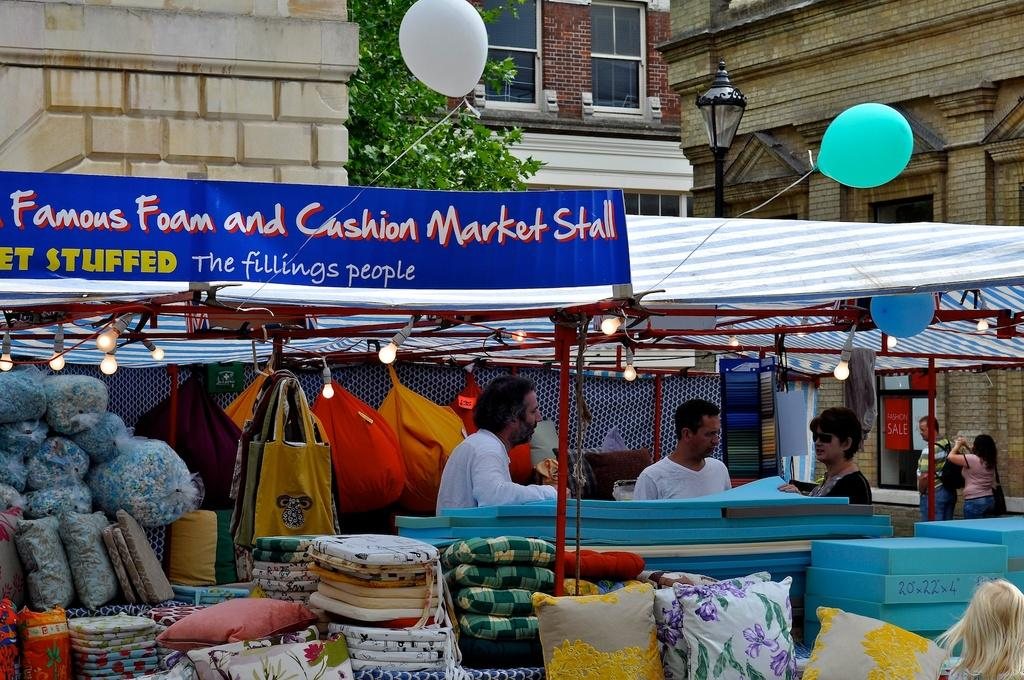What type of structures are present in the image? There are stalls in the image. How many people can be seen in the image? There are five persons in the image. What items are visible in the image that might be used for comfort or decoration? There are pillows in the image. What objects might people use to carry items in the image? There are bags in the image. What type of illumination is present in the image? There are lights in the image. What additional decorative items can be seen in the image? There are balloons in the image. What type of items are being sold or displayed in the stalls? There are clothes in the image. What is the main writing surface in the image? There is a board in the image. What background elements can be seen in the image? There is a pole, a tree, and buildings in the background of the image. How many horses are tied to the pole in the background of the image? There are no horses present in the image; only a pole, a tree, and buildings can be seen in the background. What type of boat is floating in the air above the stalls in the image? There are no boats present in the image; the focus is on the stalls, people, and various items. 